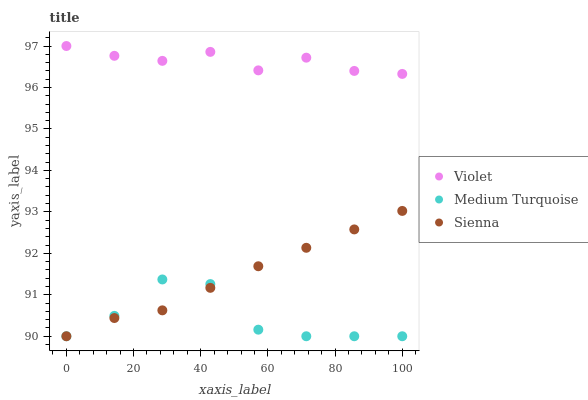Does Medium Turquoise have the minimum area under the curve?
Answer yes or no. Yes. Does Violet have the maximum area under the curve?
Answer yes or no. Yes. Does Violet have the minimum area under the curve?
Answer yes or no. No. Does Medium Turquoise have the maximum area under the curve?
Answer yes or no. No. Is Sienna the smoothest?
Answer yes or no. Yes. Is Medium Turquoise the roughest?
Answer yes or no. Yes. Is Violet the smoothest?
Answer yes or no. No. Is Violet the roughest?
Answer yes or no. No. Does Sienna have the lowest value?
Answer yes or no. Yes. Does Violet have the lowest value?
Answer yes or no. No. Does Violet have the highest value?
Answer yes or no. Yes. Does Medium Turquoise have the highest value?
Answer yes or no. No. Is Medium Turquoise less than Violet?
Answer yes or no. Yes. Is Violet greater than Medium Turquoise?
Answer yes or no. Yes. Does Medium Turquoise intersect Sienna?
Answer yes or no. Yes. Is Medium Turquoise less than Sienna?
Answer yes or no. No. Is Medium Turquoise greater than Sienna?
Answer yes or no. No. Does Medium Turquoise intersect Violet?
Answer yes or no. No. 